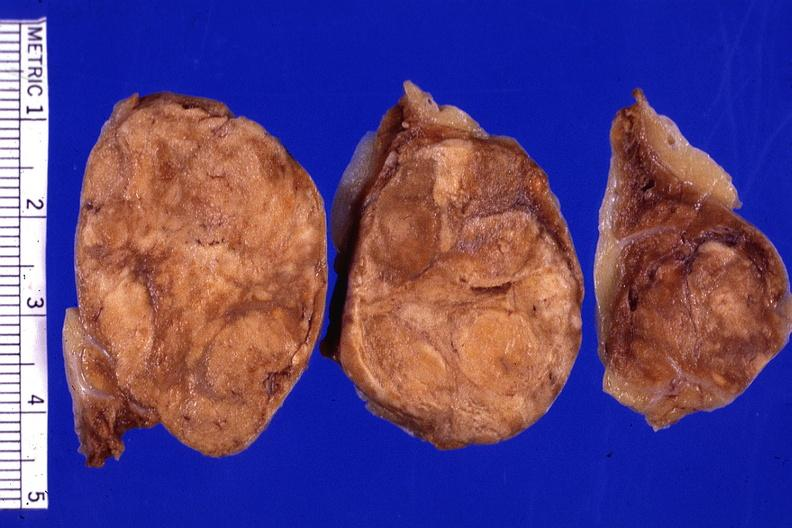s adenoma present?
Answer the question using a single word or phrase. Yes 